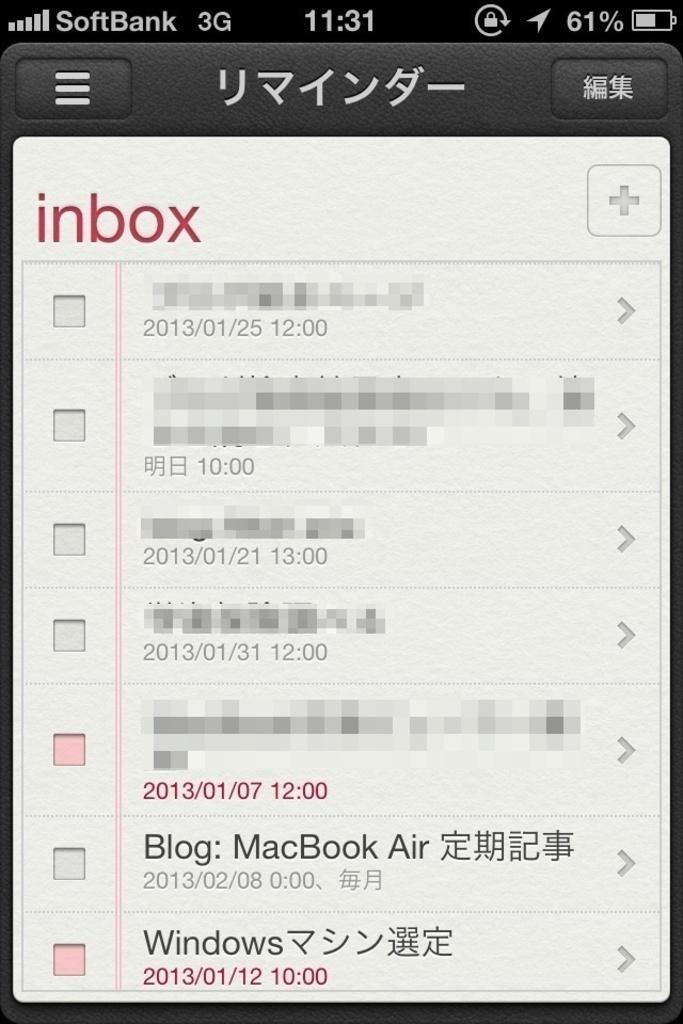Provide a one-sentence caption for the provided image. The image includes a message about a MacBook Air. 